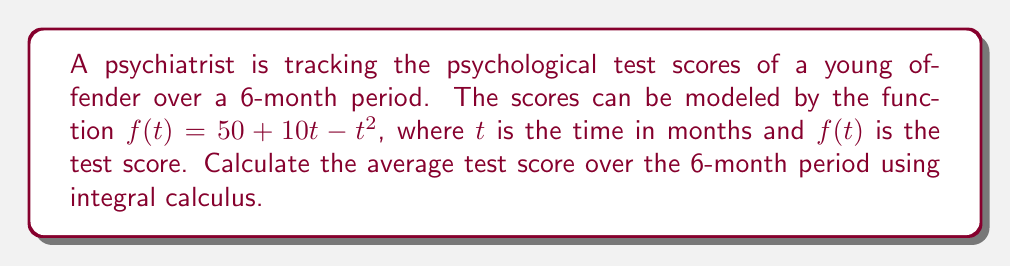What is the answer to this math problem? To find the average test score over the 6-month period, we need to:

1. Calculate the area under the curve $f(t) = 50 + 10t - t^2$ from $t=0$ to $t=6$.
2. Divide this area by the length of the time interval (6 months).

Step 1: Calculate the definite integral

$$\int_0^6 (50 + 10t - t^2) dt$$

Step 2: Integrate each term
$$\left[50t + 5t^2 - \frac{1}{3}t^3\right]_0^6$$

Step 3: Evaluate the integral
$$\left(50(6) + 5(6^2) - \frac{1}{3}(6^3)\right) - \left(50(0) + 5(0^2) - \frac{1}{3}(0^3)\right)$$
$$= \left(300 + 180 - 72\right) - (0)$$
$$= 408$$

Step 4: Divide by the time interval
Average score = $\frac{408}{6} = 68$

Therefore, the average test score over the 6-month period is 68.
Answer: 68 